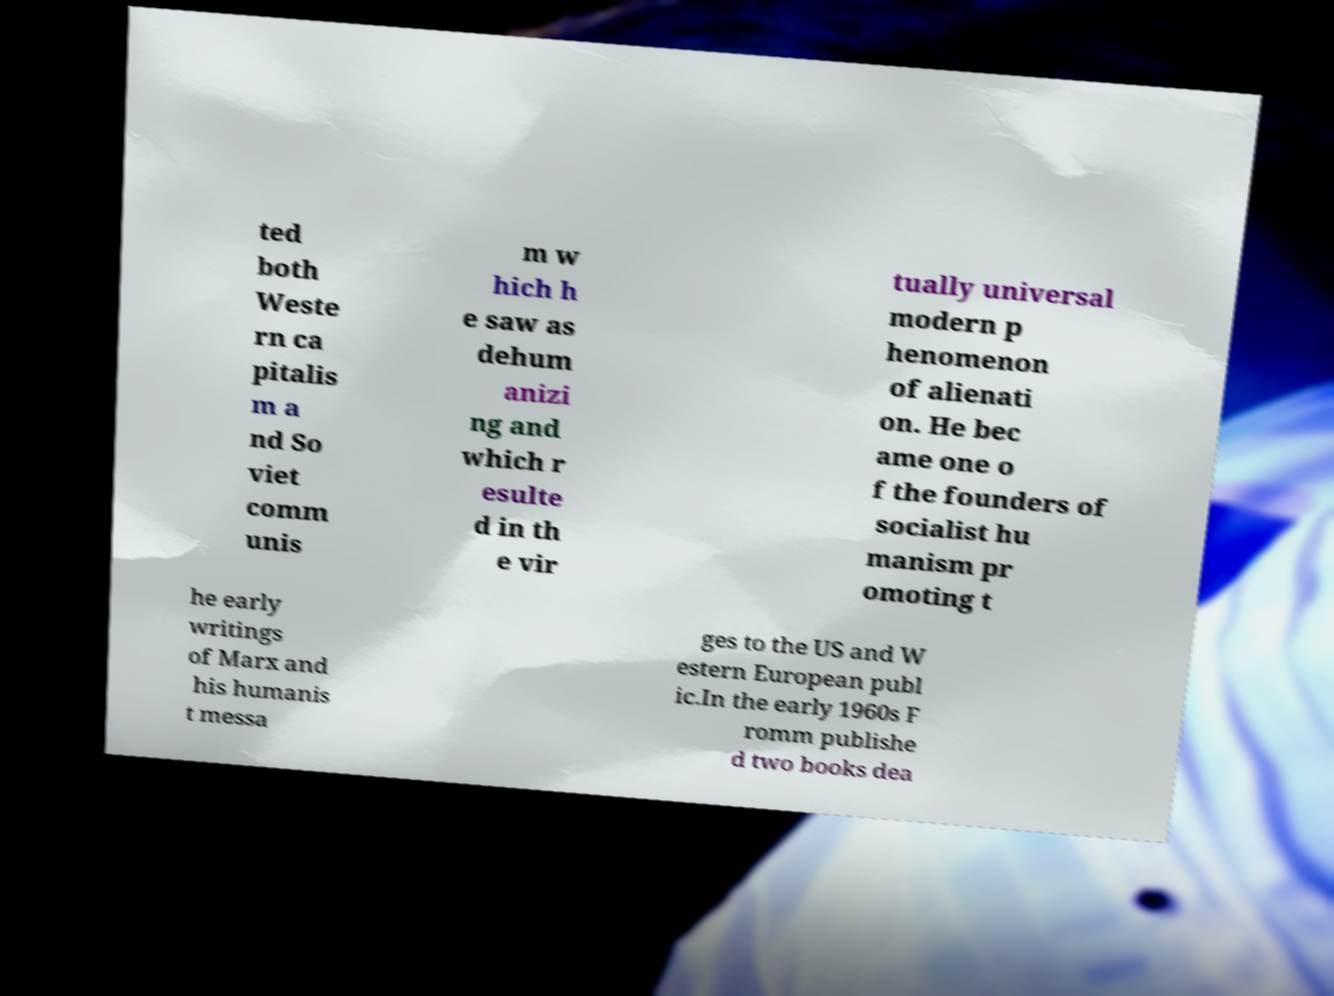Please identify and transcribe the text found in this image. ted both Weste rn ca pitalis m a nd So viet comm unis m w hich h e saw as dehum anizi ng and which r esulte d in th e vir tually universal modern p henomenon of alienati on. He bec ame one o f the founders of socialist hu manism pr omoting t he early writings of Marx and his humanis t messa ges to the US and W estern European publ ic.In the early 1960s F romm publishe d two books dea 